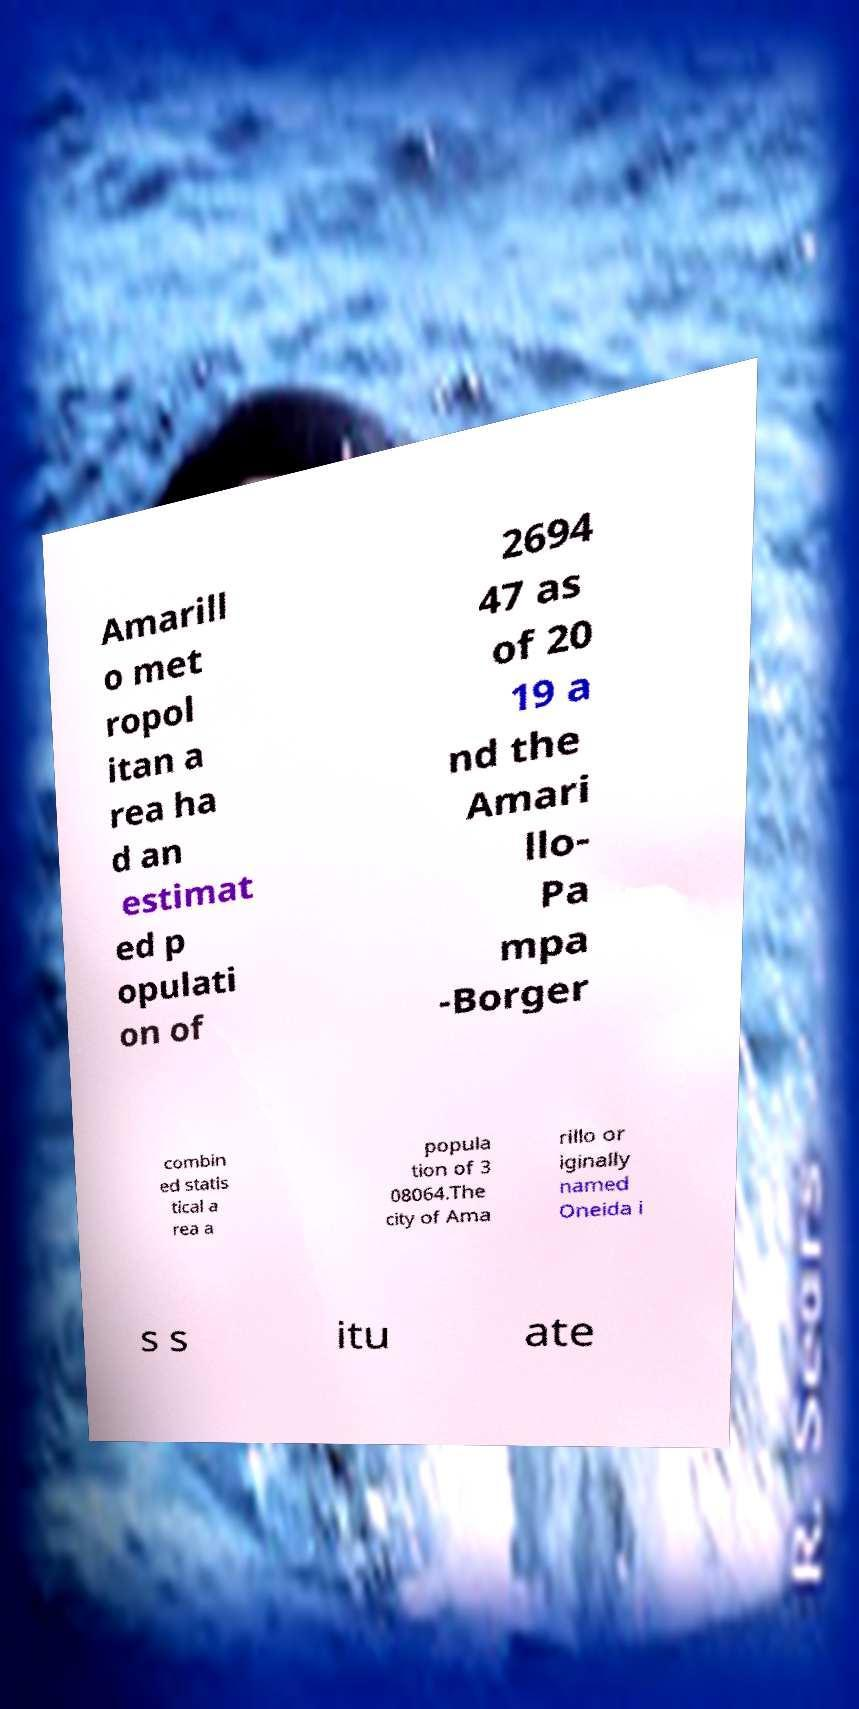Can you accurately transcribe the text from the provided image for me? Amarill o met ropol itan a rea ha d an estimat ed p opulati on of 2694 47 as of 20 19 a nd the Amari llo- Pa mpa -Borger combin ed statis tical a rea a popula tion of 3 08064.The city of Ama rillo or iginally named Oneida i s s itu ate 